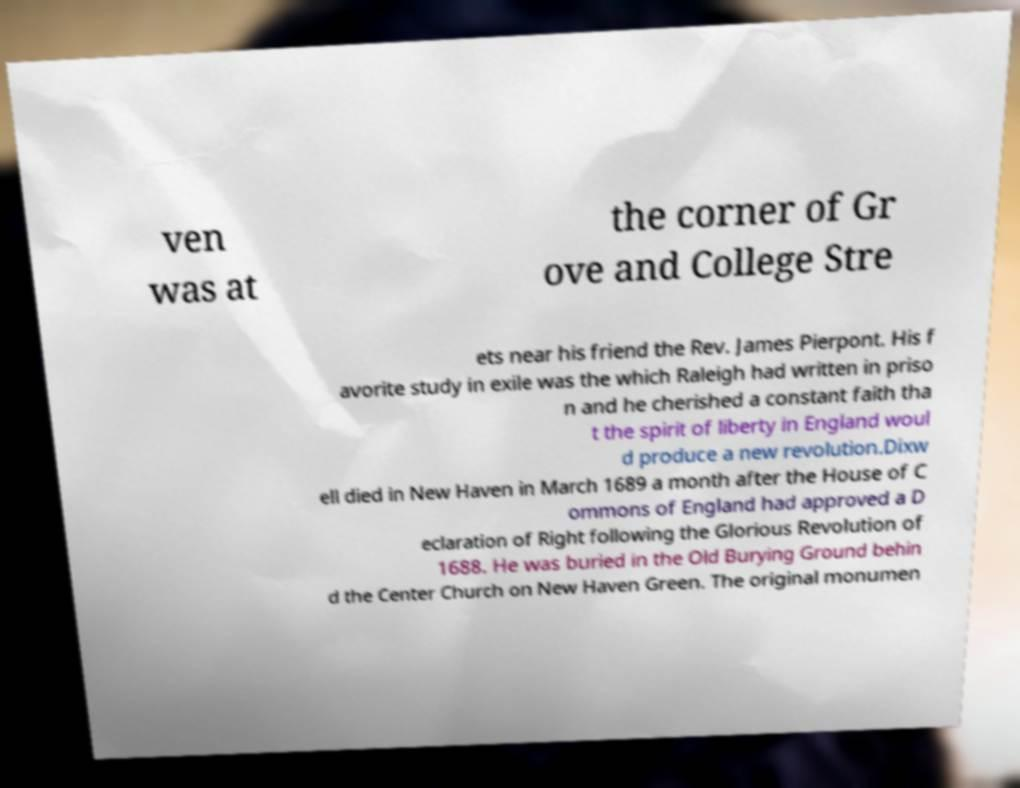What messages or text are displayed in this image? I need them in a readable, typed format. ven was at the corner of Gr ove and College Stre ets near his friend the Rev. James Pierpont. His f avorite study in exile was the which Raleigh had written in priso n and he cherished a constant faith tha t the spirit of liberty in England woul d produce a new revolution.Dixw ell died in New Haven in March 1689 a month after the House of C ommons of England had approved a D eclaration of Right following the Glorious Revolution of 1688. He was buried in the Old Burying Ground behin d the Center Church on New Haven Green. The original monumen 